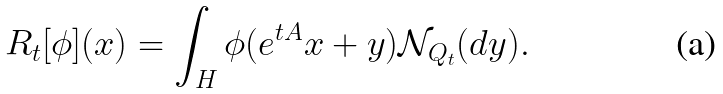<formula> <loc_0><loc_0><loc_500><loc_500>R _ { t } [ \phi ] ( x ) = \int _ { H } \phi ( e ^ { t A } x + y ) \mathcal { N } _ { Q _ { t } } ( d y ) .</formula> 